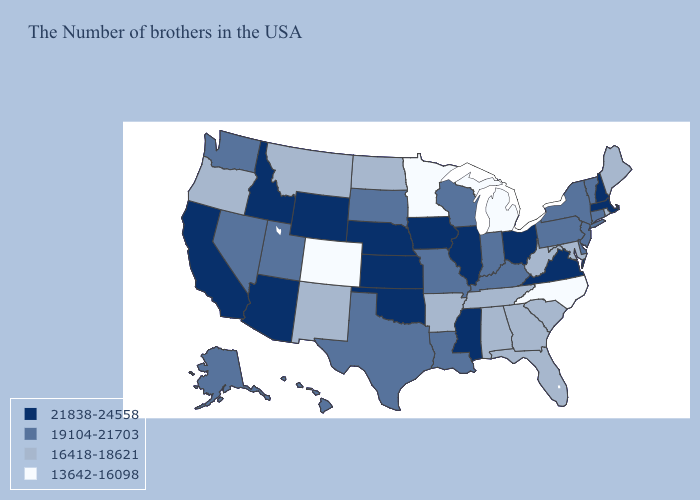What is the value of Arizona?
Answer briefly. 21838-24558. Among the states that border Wisconsin , does Minnesota have the highest value?
Short answer required. No. What is the highest value in the South ?
Concise answer only. 21838-24558. What is the value of Georgia?
Quick response, please. 16418-18621. Which states have the highest value in the USA?
Give a very brief answer. Massachusetts, New Hampshire, Virginia, Ohio, Illinois, Mississippi, Iowa, Kansas, Nebraska, Oklahoma, Wyoming, Arizona, Idaho, California. What is the value of Kentucky?
Write a very short answer. 19104-21703. What is the value of Florida?
Concise answer only. 16418-18621. Is the legend a continuous bar?
Keep it brief. No. Does the first symbol in the legend represent the smallest category?
Keep it brief. No. Does Kansas have the lowest value in the USA?
Give a very brief answer. No. What is the highest value in the Northeast ?
Answer briefly. 21838-24558. What is the value of Hawaii?
Be succinct. 19104-21703. Does the first symbol in the legend represent the smallest category?
Keep it brief. No. Name the states that have a value in the range 19104-21703?
Short answer required. Vermont, Connecticut, New York, New Jersey, Delaware, Pennsylvania, Kentucky, Indiana, Wisconsin, Louisiana, Missouri, Texas, South Dakota, Utah, Nevada, Washington, Alaska, Hawaii. Does the map have missing data?
Be succinct. No. 